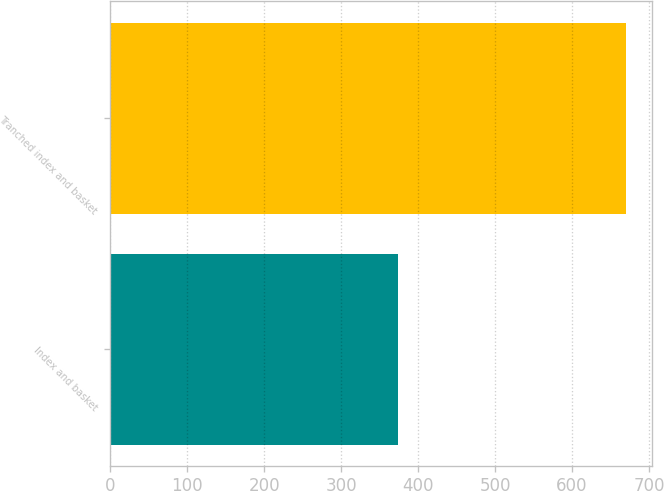Convert chart to OTSL. <chart><loc_0><loc_0><loc_500><loc_500><bar_chart><fcel>Index and basket<fcel>Tranched index and basket<nl><fcel>374<fcel>670<nl></chart> 